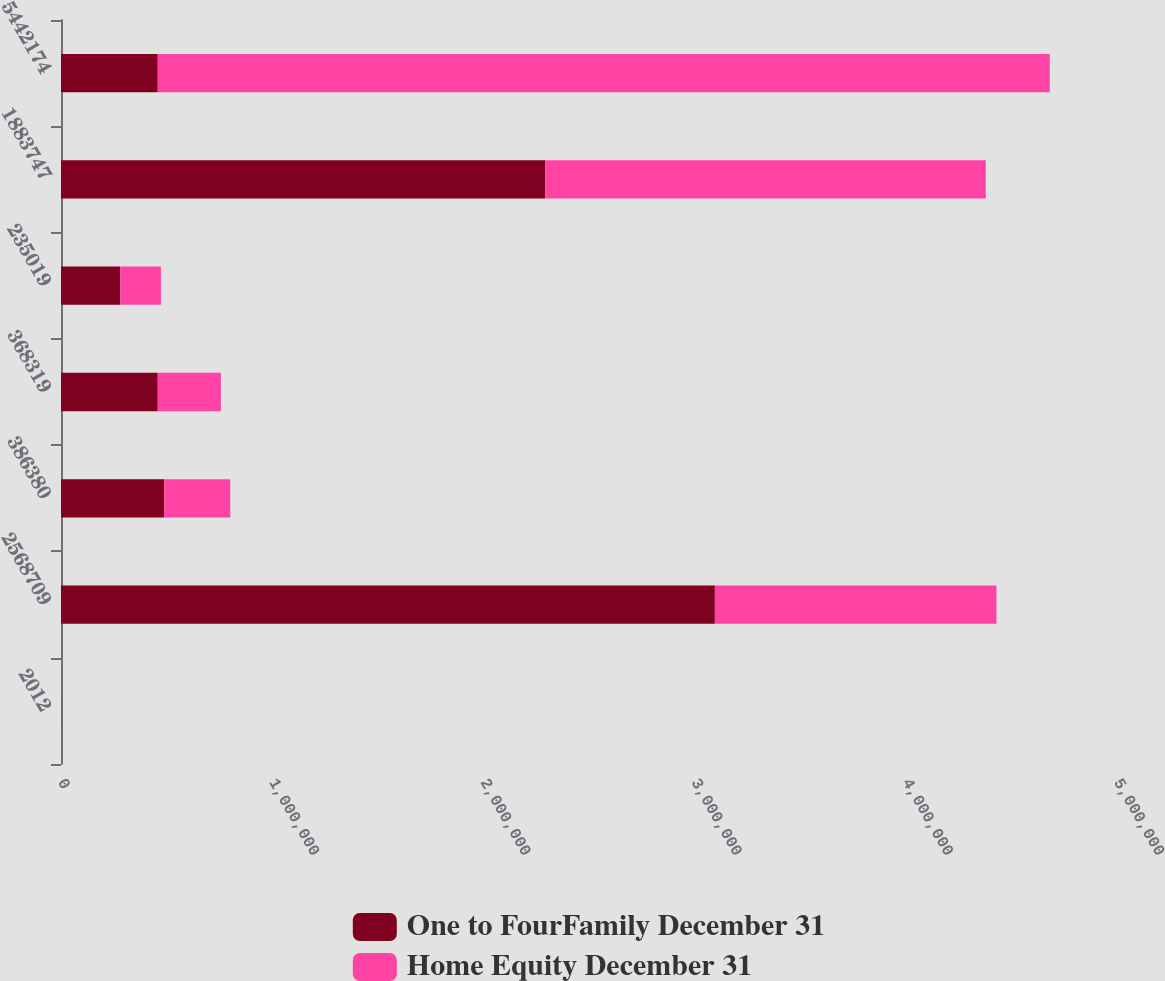Convert chart to OTSL. <chart><loc_0><loc_0><loc_500><loc_500><stacked_bar_chart><ecel><fcel>2012<fcel>2568709<fcel>386380<fcel>368319<fcel>235019<fcel>1883747<fcel>5442174<nl><fcel>One to FourFamily December 31<fcel>2011<fcel>3.09603e+06<fcel>488209<fcel>458219<fcel>280772<fcel>2.29258e+06<fcel>458219<nl><fcel>Home Equity December 31<fcel>2012<fcel>1.33332e+06<fcel>313148<fcel>298860<fcel>192143<fcel>2.08599e+06<fcel>4.22346e+06<nl></chart> 